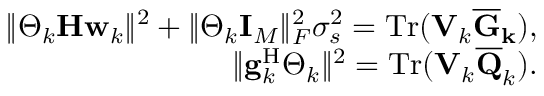Convert formula to latex. <formula><loc_0><loc_0><loc_500><loc_500>\begin{array} { r l r } & { \| \Theta _ { k } H w _ { k } \| ^ { 2 } + \| \Theta _ { k } I _ { M } \| _ { F } ^ { 2 } \sigma _ { s } ^ { 2 } = T r ( V _ { k } \overline { G } _ { k } ) , } \\ & { \| g _ { k } ^ { H } \Theta _ { k } \| ^ { 2 } = T r ( V _ { k } \overline { Q } _ { k } ) . } \end{array}</formula> 